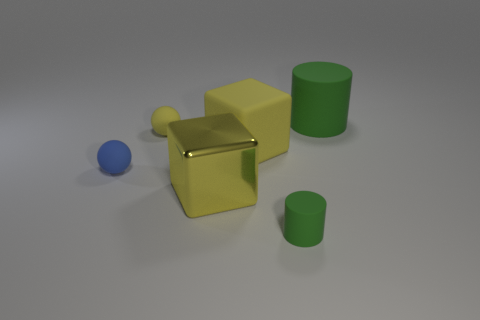Add 2 tiny red matte things. How many objects exist? 8 Subtract 2 cylinders. How many cylinders are left? 0 Subtract all cyan balls. Subtract all green cylinders. How many balls are left? 2 Subtract all yellow cubes. How many cyan spheres are left? 0 Subtract all large blocks. Subtract all large metal objects. How many objects are left? 3 Add 6 large yellow blocks. How many large yellow blocks are left? 8 Add 6 cylinders. How many cylinders exist? 8 Subtract all blue balls. How many balls are left? 1 Subtract 0 red spheres. How many objects are left? 6 Subtract all cylinders. How many objects are left? 4 